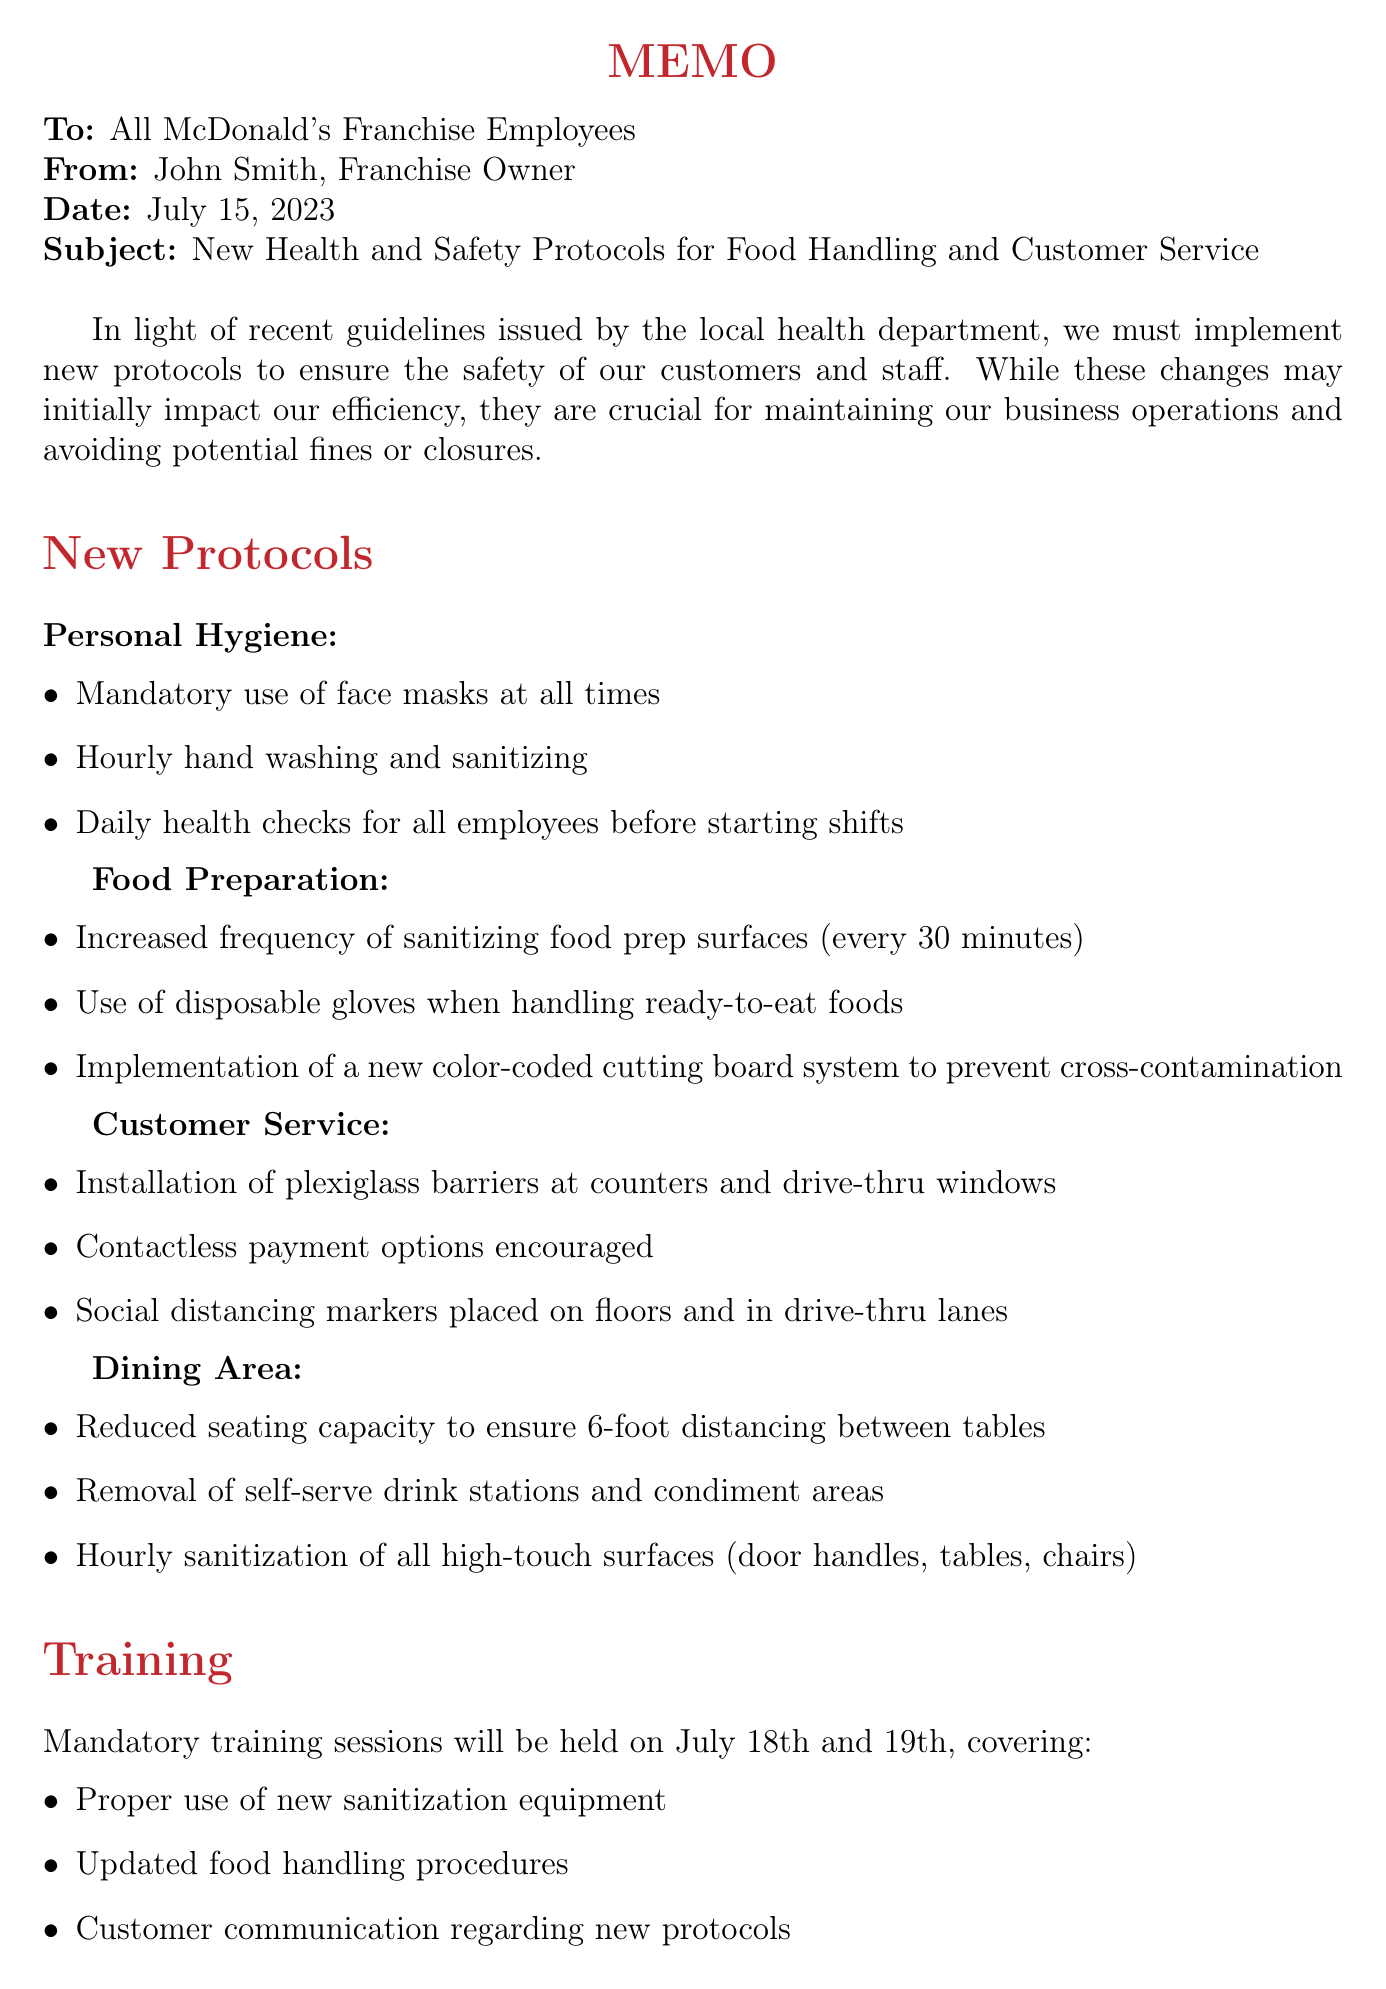what is the subject of the memo? The subject of the memo is stated clearly at the top and indicates what the memo is addressing.
Answer: New Health and Safety Protocols for Food Handling and Customer Service who is the author of the memo? The author's name is mentioned in the "from" section of the memo.
Answer: John Smith when will the mandatory training sessions be held? The dates for the training sessions are specified clearly in the training section of the memo.
Answer: July 18th and 19th what is one item required for personal hygiene? The personal hygiene section lists specific items that must be followed.
Answer: Mandatory use of face masks at all times how often should food preparation surfaces be sanitized? The frequency of sanitizing food prep surfaces is mentioned in the food preparation section.
Answer: Every 30 minutes what will happen if employees fail to comply with the new protocols? The consequences of non-compliance are outlined in the compliance section of the memo.
Answer: Disciplinary action, including termination what is the purpose of the new health and safety protocols? The introduction explains the reason behind implementing new protocols.
Answer: Ensuring the safety of our customers and staff how is the seating capacity in the dining area affected? The dining area section specifies changes to seating arrangements.
Answer: Reduced seating capacity to ensure 6-foot distancing between tables 